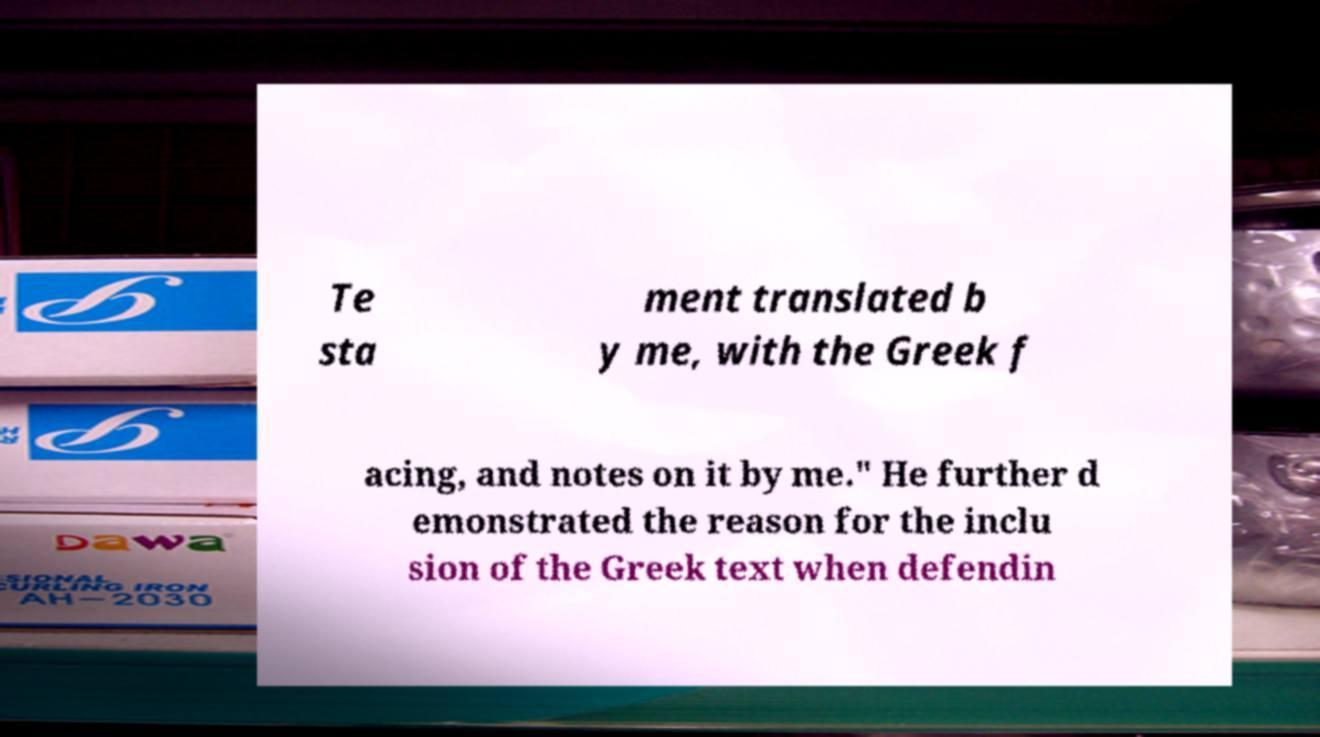Please identify and transcribe the text found in this image. Te sta ment translated b y me, with the Greek f acing, and notes on it by me." He further d emonstrated the reason for the inclu sion of the Greek text when defendin 